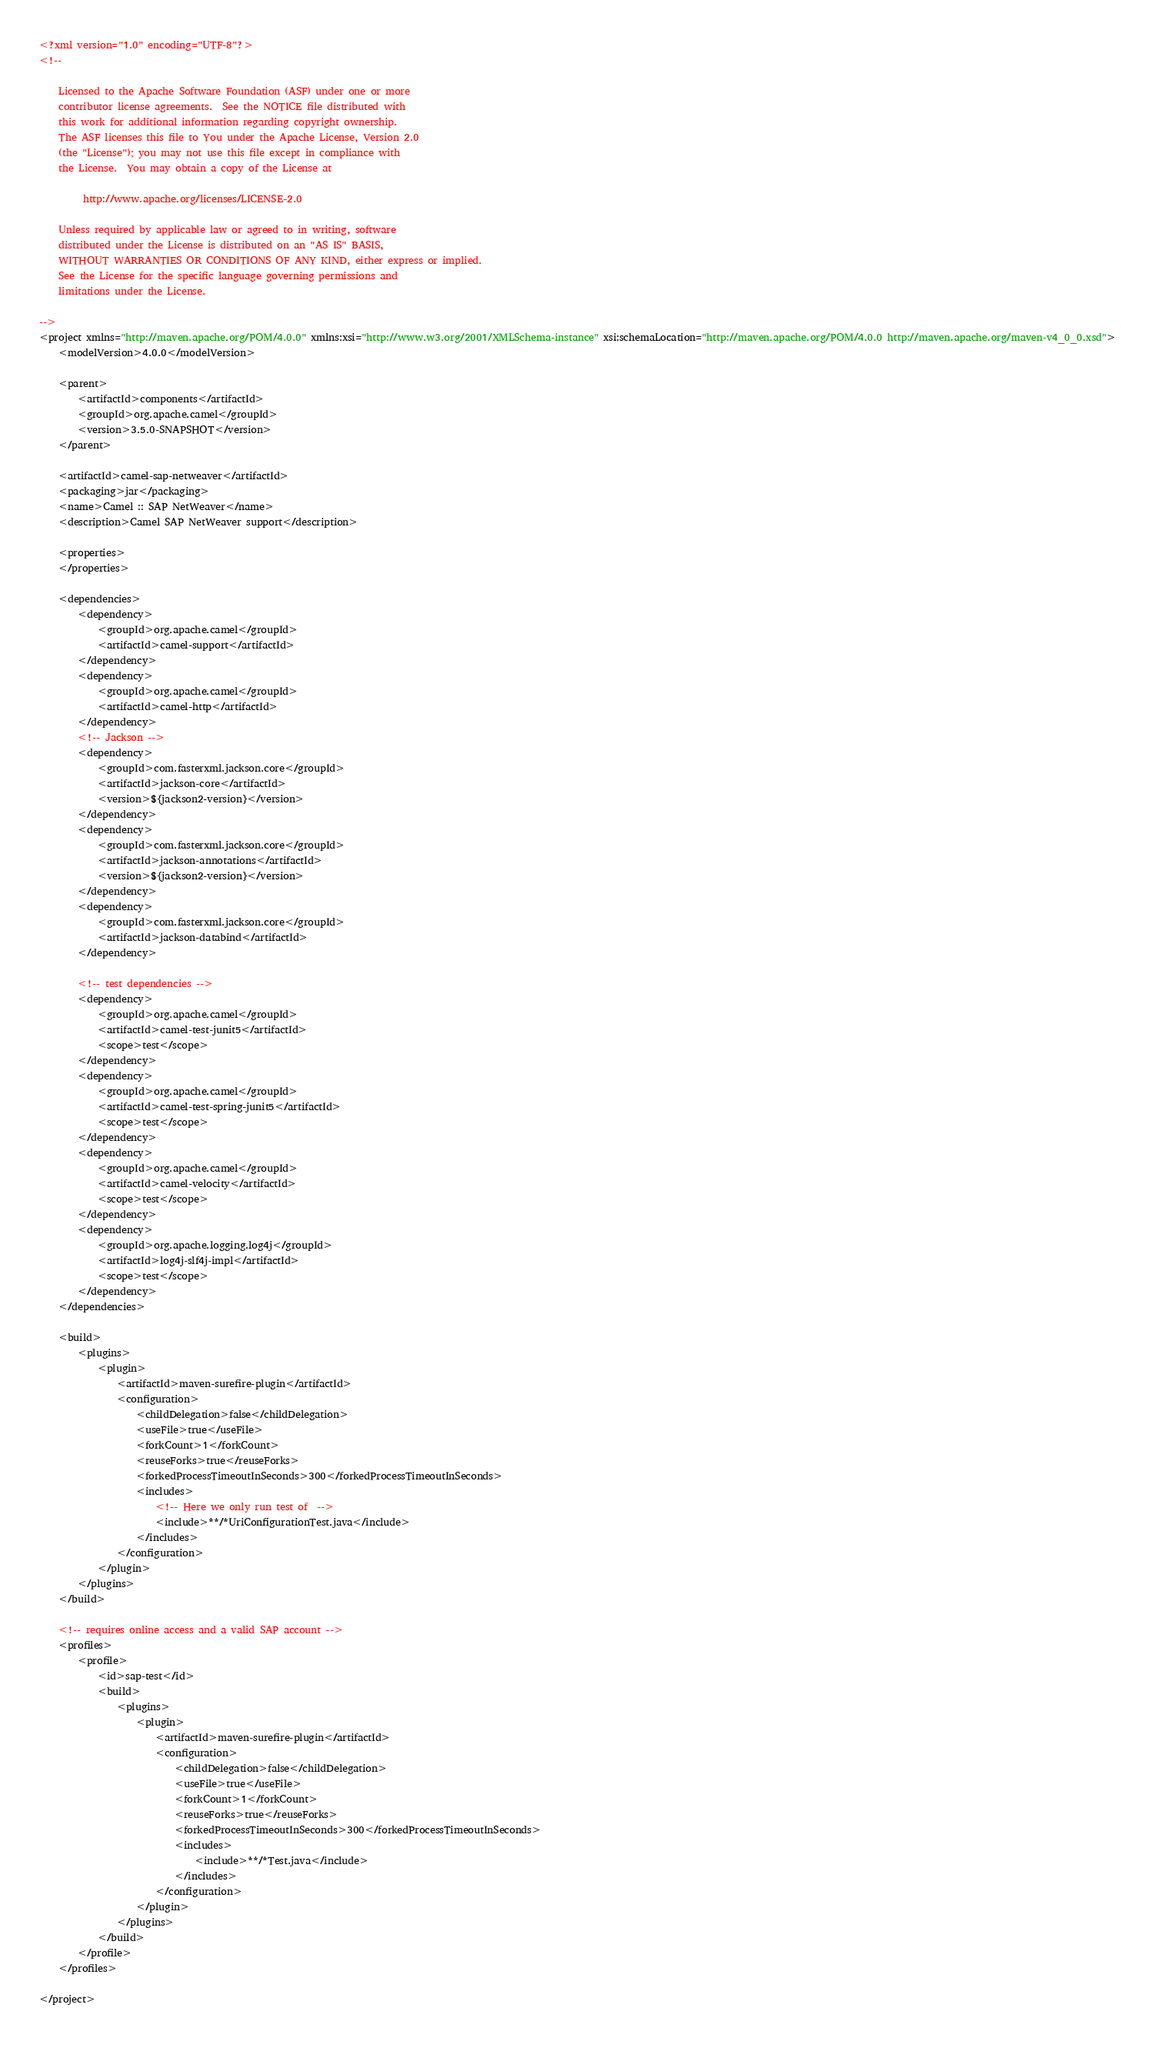Convert code to text. <code><loc_0><loc_0><loc_500><loc_500><_XML_><?xml version="1.0" encoding="UTF-8"?>
<!--

    Licensed to the Apache Software Foundation (ASF) under one or more
    contributor license agreements.  See the NOTICE file distributed with
    this work for additional information regarding copyright ownership.
    The ASF licenses this file to You under the Apache License, Version 2.0
    (the "License"); you may not use this file except in compliance with
    the License.  You may obtain a copy of the License at

         http://www.apache.org/licenses/LICENSE-2.0

    Unless required by applicable law or agreed to in writing, software
    distributed under the License is distributed on an "AS IS" BASIS,
    WITHOUT WARRANTIES OR CONDITIONS OF ANY KIND, either express or implied.
    See the License for the specific language governing permissions and
    limitations under the License.

-->
<project xmlns="http://maven.apache.org/POM/4.0.0" xmlns:xsi="http://www.w3.org/2001/XMLSchema-instance" xsi:schemaLocation="http://maven.apache.org/POM/4.0.0 http://maven.apache.org/maven-v4_0_0.xsd">
    <modelVersion>4.0.0</modelVersion>

    <parent>
        <artifactId>components</artifactId>
        <groupId>org.apache.camel</groupId>
        <version>3.5.0-SNAPSHOT</version>
    </parent>

    <artifactId>camel-sap-netweaver</artifactId>
    <packaging>jar</packaging>
    <name>Camel :: SAP NetWeaver</name>
    <description>Camel SAP NetWeaver support</description>

    <properties>
    </properties>

    <dependencies>
        <dependency>
            <groupId>org.apache.camel</groupId>
            <artifactId>camel-support</artifactId>
        </dependency>
        <dependency>
            <groupId>org.apache.camel</groupId>
            <artifactId>camel-http</artifactId>
        </dependency>
        <!-- Jackson -->
        <dependency>
            <groupId>com.fasterxml.jackson.core</groupId>
            <artifactId>jackson-core</artifactId>
            <version>${jackson2-version}</version>
        </dependency>
        <dependency>
            <groupId>com.fasterxml.jackson.core</groupId>
            <artifactId>jackson-annotations</artifactId>
            <version>${jackson2-version}</version>
        </dependency>
        <dependency>
            <groupId>com.fasterxml.jackson.core</groupId>
            <artifactId>jackson-databind</artifactId>
        </dependency>

        <!-- test dependencies -->
        <dependency>
            <groupId>org.apache.camel</groupId>
            <artifactId>camel-test-junit5</artifactId>
            <scope>test</scope>
        </dependency>
        <dependency>
            <groupId>org.apache.camel</groupId>
            <artifactId>camel-test-spring-junit5</artifactId>
            <scope>test</scope>
        </dependency>
        <dependency>
            <groupId>org.apache.camel</groupId>
            <artifactId>camel-velocity</artifactId>
            <scope>test</scope>
        </dependency>
        <dependency>
            <groupId>org.apache.logging.log4j</groupId>
            <artifactId>log4j-slf4j-impl</artifactId>
            <scope>test</scope>
        </dependency>
    </dependencies>

    <build>
        <plugins>
            <plugin>
                <artifactId>maven-surefire-plugin</artifactId>
                <configuration>
                    <childDelegation>false</childDelegation>
                    <useFile>true</useFile>
                    <forkCount>1</forkCount>
                    <reuseForks>true</reuseForks>
                    <forkedProcessTimeoutInSeconds>300</forkedProcessTimeoutInSeconds>
                    <includes>
                        <!-- Here we only run test of  -->
                        <include>**/*UriConfigurationTest.java</include>
                    </includes>
                </configuration>
            </plugin>
        </plugins>
    </build>

    <!-- requires online access and a valid SAP account -->
    <profiles>
        <profile>
            <id>sap-test</id>
            <build>
                <plugins>
                    <plugin>
                        <artifactId>maven-surefire-plugin</artifactId>
                        <configuration>
                            <childDelegation>false</childDelegation>
                            <useFile>true</useFile>
                            <forkCount>1</forkCount>
                            <reuseForks>true</reuseForks>
                            <forkedProcessTimeoutInSeconds>300</forkedProcessTimeoutInSeconds>
                            <includes>
                                <include>**/*Test.java</include>
                            </includes>
                        </configuration>
                    </plugin>
                </plugins>
            </build>
        </profile>
    </profiles>

</project>
</code> 